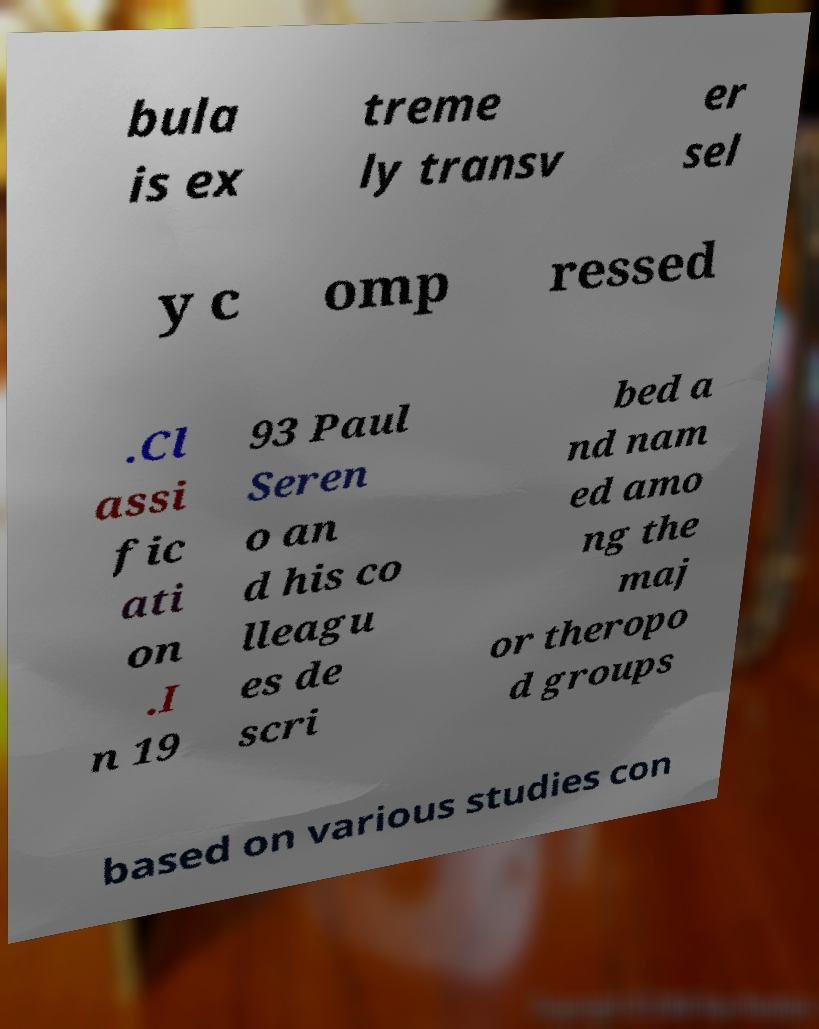Can you accurately transcribe the text from the provided image for me? bula is ex treme ly transv er sel y c omp ressed .Cl assi fic ati on .I n 19 93 Paul Seren o an d his co lleagu es de scri bed a nd nam ed amo ng the maj or theropo d groups based on various studies con 